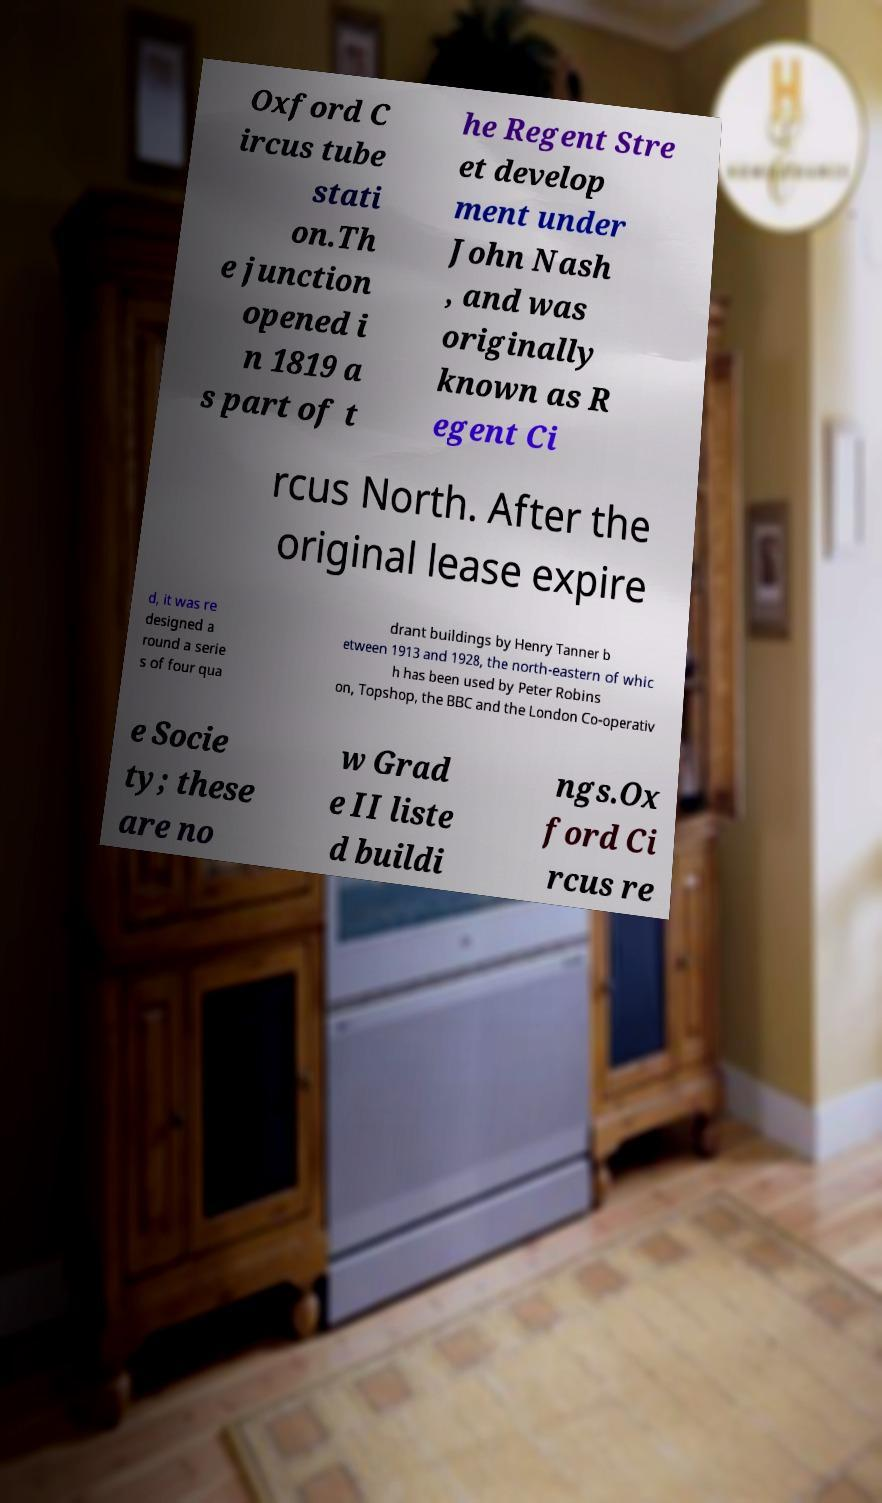Can you accurately transcribe the text from the provided image for me? Oxford C ircus tube stati on.Th e junction opened i n 1819 a s part of t he Regent Stre et develop ment under John Nash , and was originally known as R egent Ci rcus North. After the original lease expire d, it was re designed a round a serie s of four qua drant buildings by Henry Tanner b etween 1913 and 1928, the north-eastern of whic h has been used by Peter Robins on, Topshop, the BBC and the London Co-operativ e Socie ty; these are no w Grad e II liste d buildi ngs.Ox ford Ci rcus re 